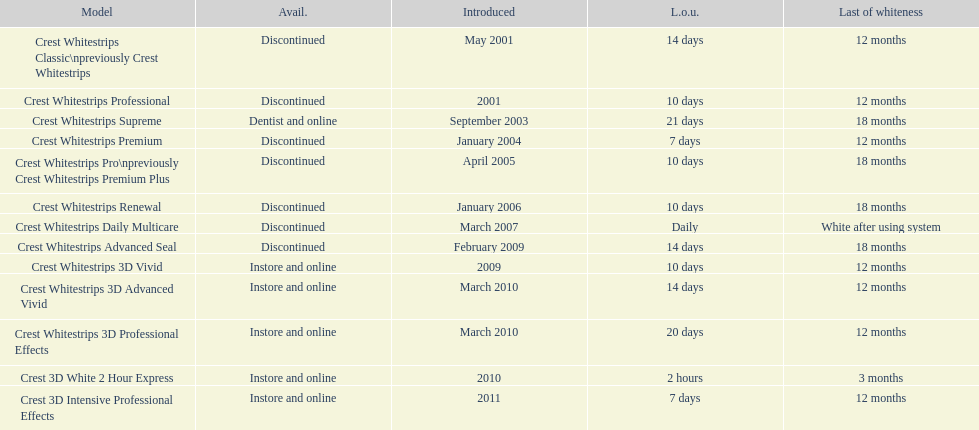Which product had a longer usage duration, crest whitestrips classic or crest whitestrips 3d vivid? Crest Whitestrips Classic. 